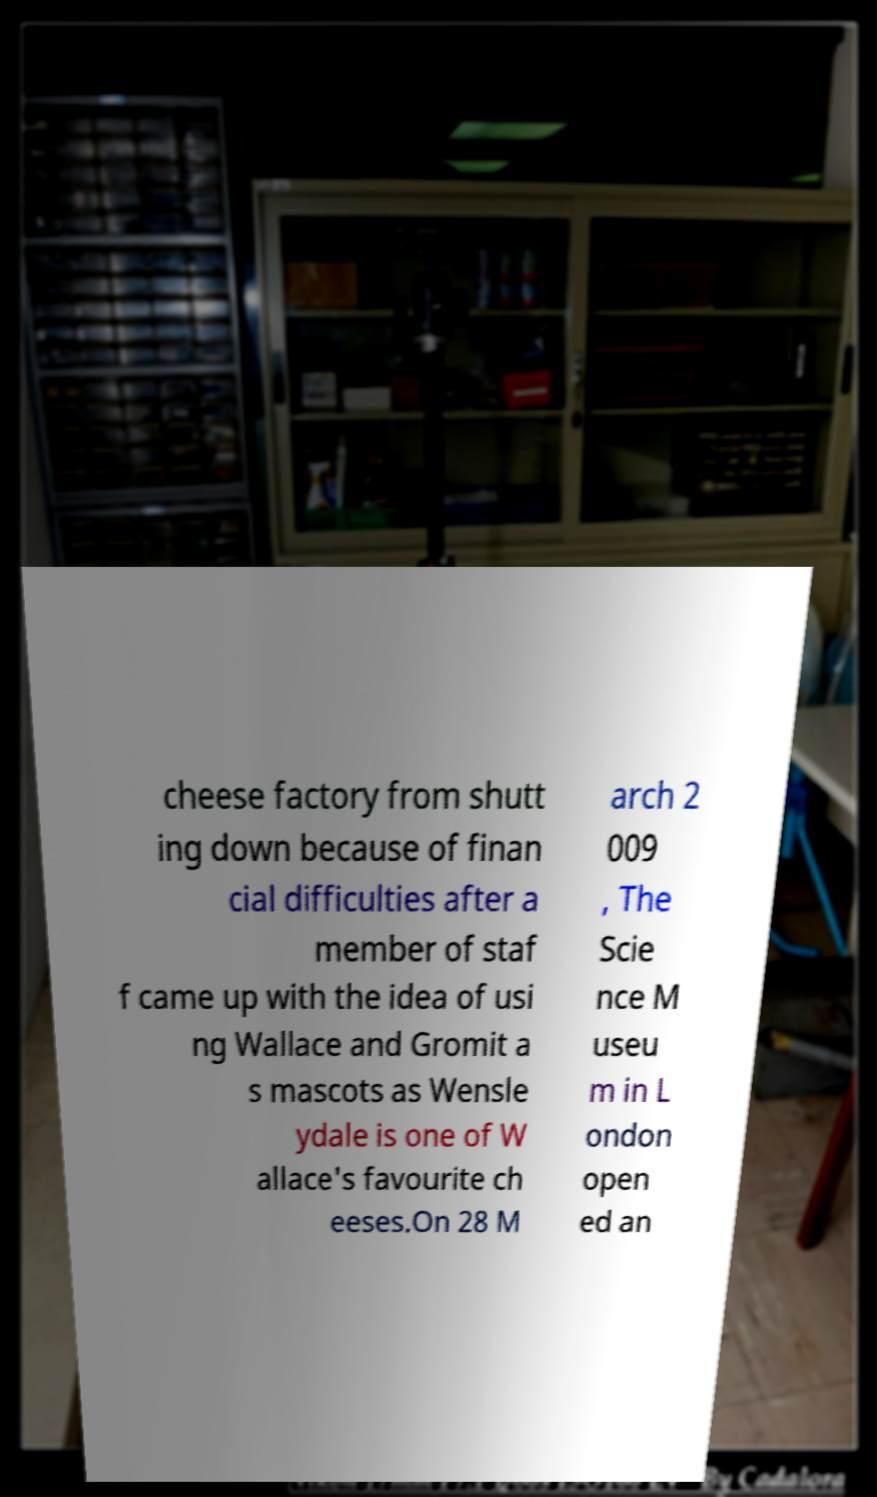I need the written content from this picture converted into text. Can you do that? cheese factory from shutt ing down because of finan cial difficulties after a member of staf f came up with the idea of usi ng Wallace and Gromit a s mascots as Wensle ydale is one of W allace's favourite ch eeses.On 28 M arch 2 009 , The Scie nce M useu m in L ondon open ed an 